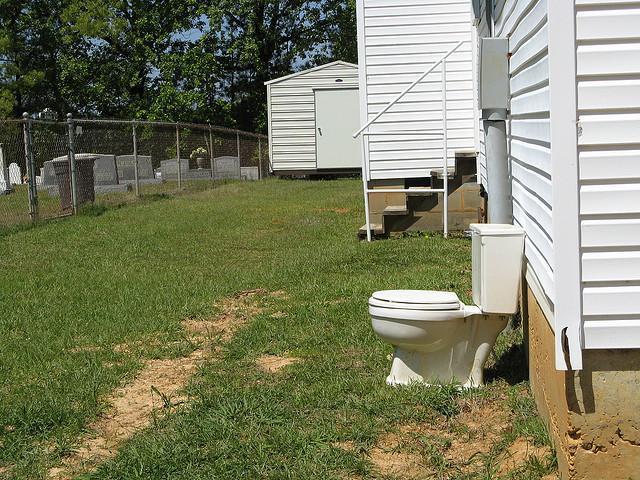How many steps are there?
Give a very brief answer. 5. How many rings is the man wearing?
Give a very brief answer. 0. 